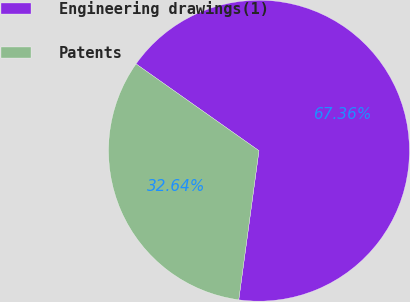Convert chart to OTSL. <chart><loc_0><loc_0><loc_500><loc_500><pie_chart><fcel>Engineering drawings(1)<fcel>Patents<nl><fcel>67.36%<fcel>32.64%<nl></chart> 